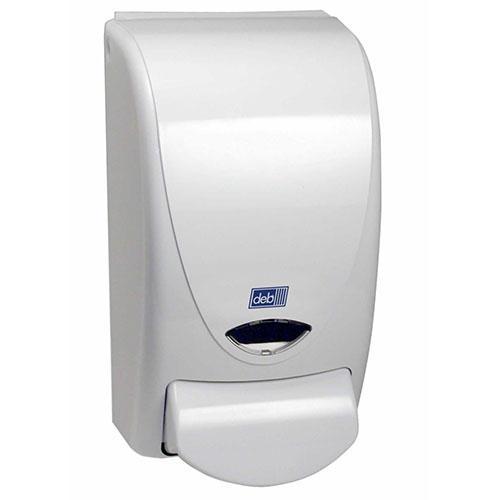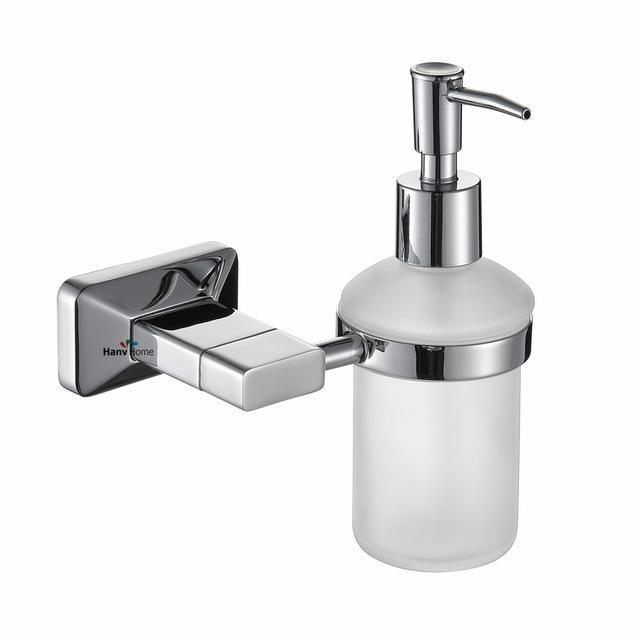The first image is the image on the left, the second image is the image on the right. For the images displayed, is the sentence "The left and right image contains the same number of wall hanging soap dispensers." factually correct? Answer yes or no. Yes. 